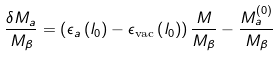<formula> <loc_0><loc_0><loc_500><loc_500>\frac { \delta M _ { a } } { M _ { \beta } } = \left ( \epsilon _ { a } \left ( l _ { 0 } \right ) - \epsilon _ { \text {vac} } \left ( l _ { 0 } \right ) \right ) \frac { M } { M _ { \beta } } - \frac { M ^ { ( 0 ) } _ { a } } { M _ { \beta } }</formula> 